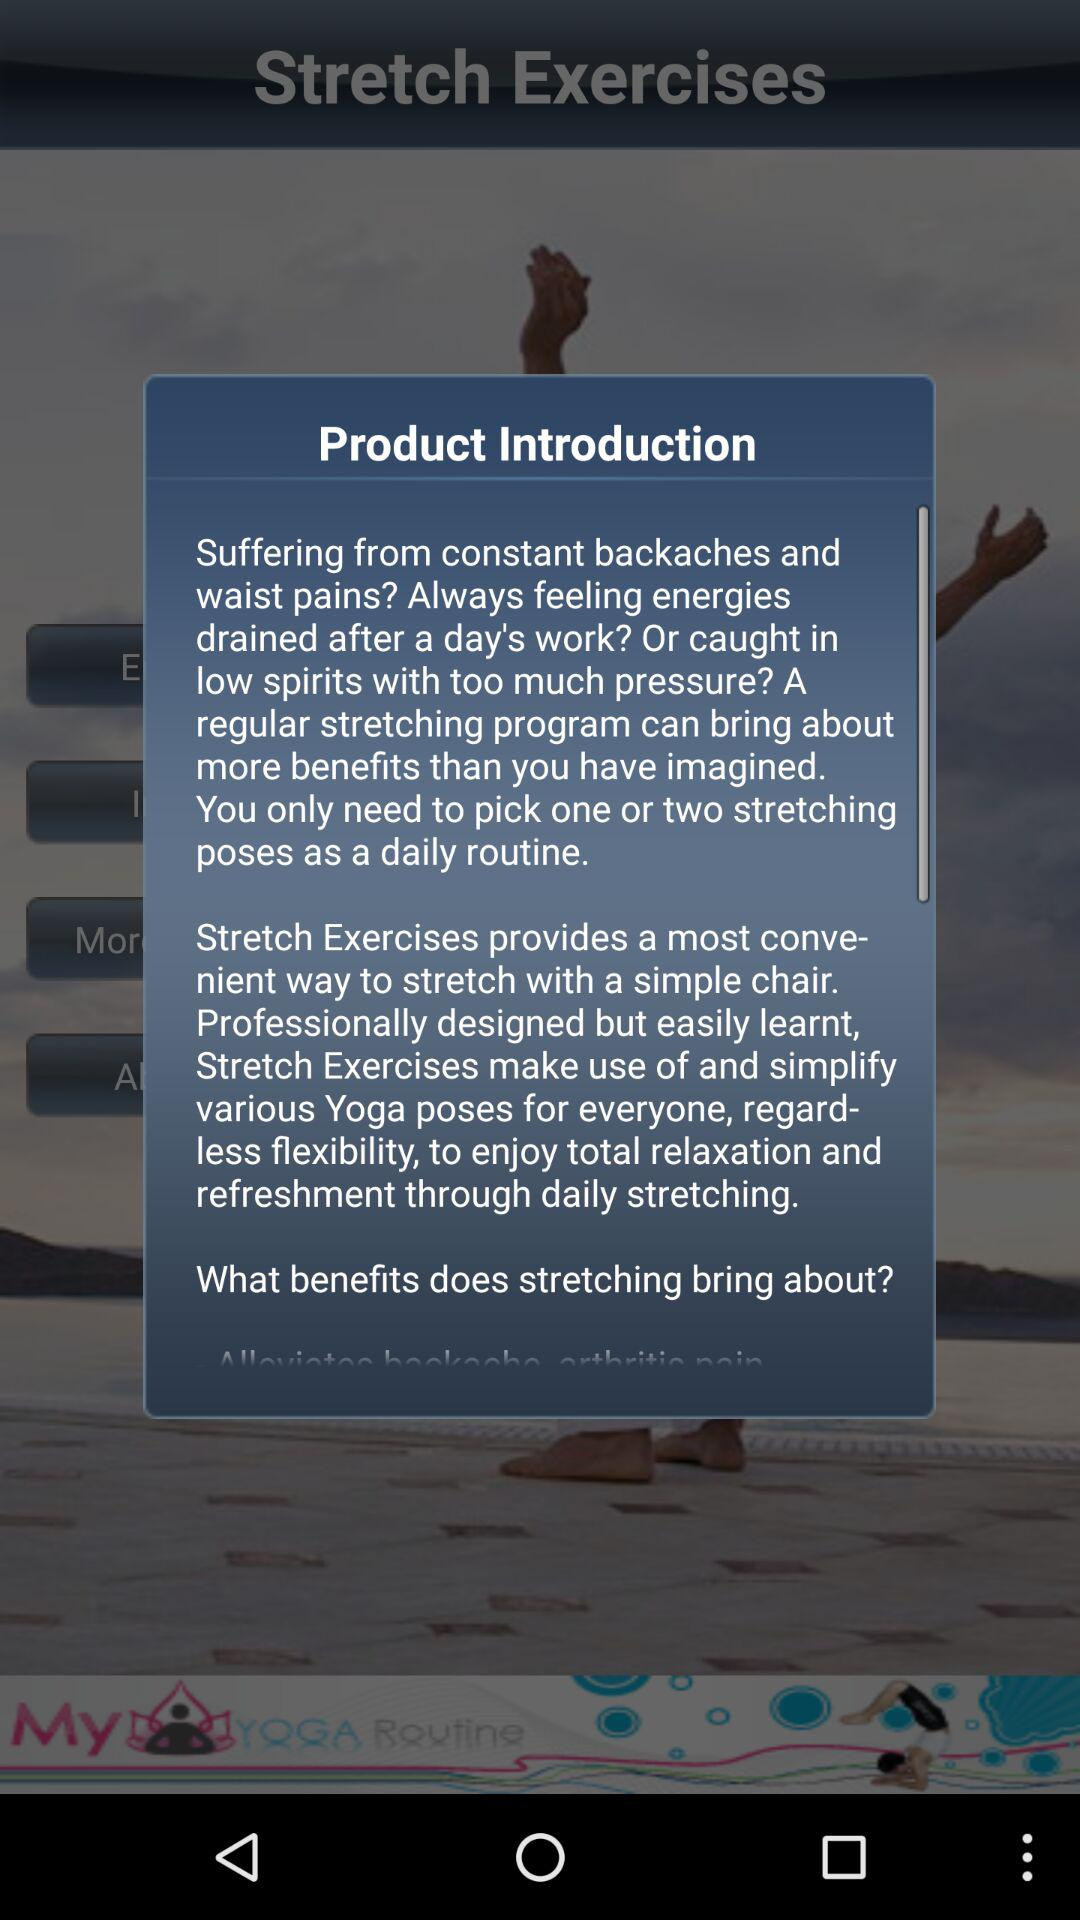How many stretching exercises are needed to be picked daily? The number of stretching exercises that are needed to be picked daily is one or two. 